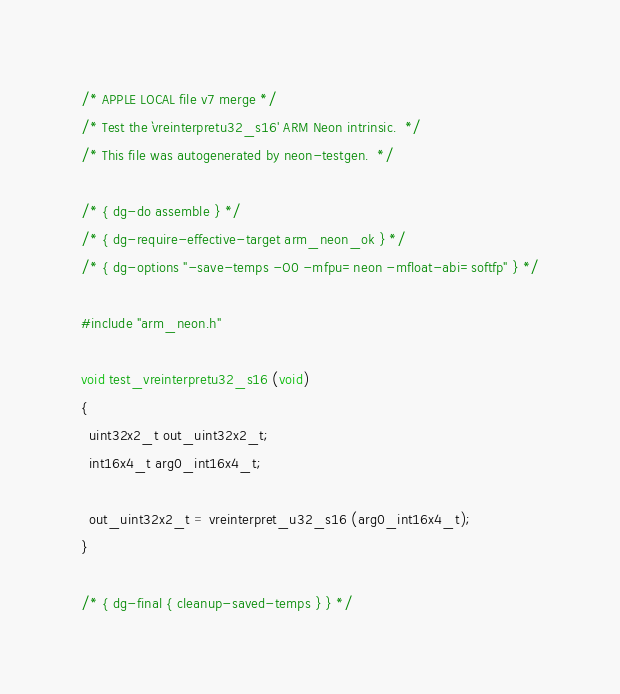<code> <loc_0><loc_0><loc_500><loc_500><_C_>/* APPLE LOCAL file v7 merge */
/* Test the `vreinterpretu32_s16' ARM Neon intrinsic.  */
/* This file was autogenerated by neon-testgen.  */

/* { dg-do assemble } */
/* { dg-require-effective-target arm_neon_ok } */
/* { dg-options "-save-temps -O0 -mfpu=neon -mfloat-abi=softfp" } */

#include "arm_neon.h"

void test_vreinterpretu32_s16 (void)
{
  uint32x2_t out_uint32x2_t;
  int16x4_t arg0_int16x4_t;

  out_uint32x2_t = vreinterpret_u32_s16 (arg0_int16x4_t);
}

/* { dg-final { cleanup-saved-temps } } */
</code> 